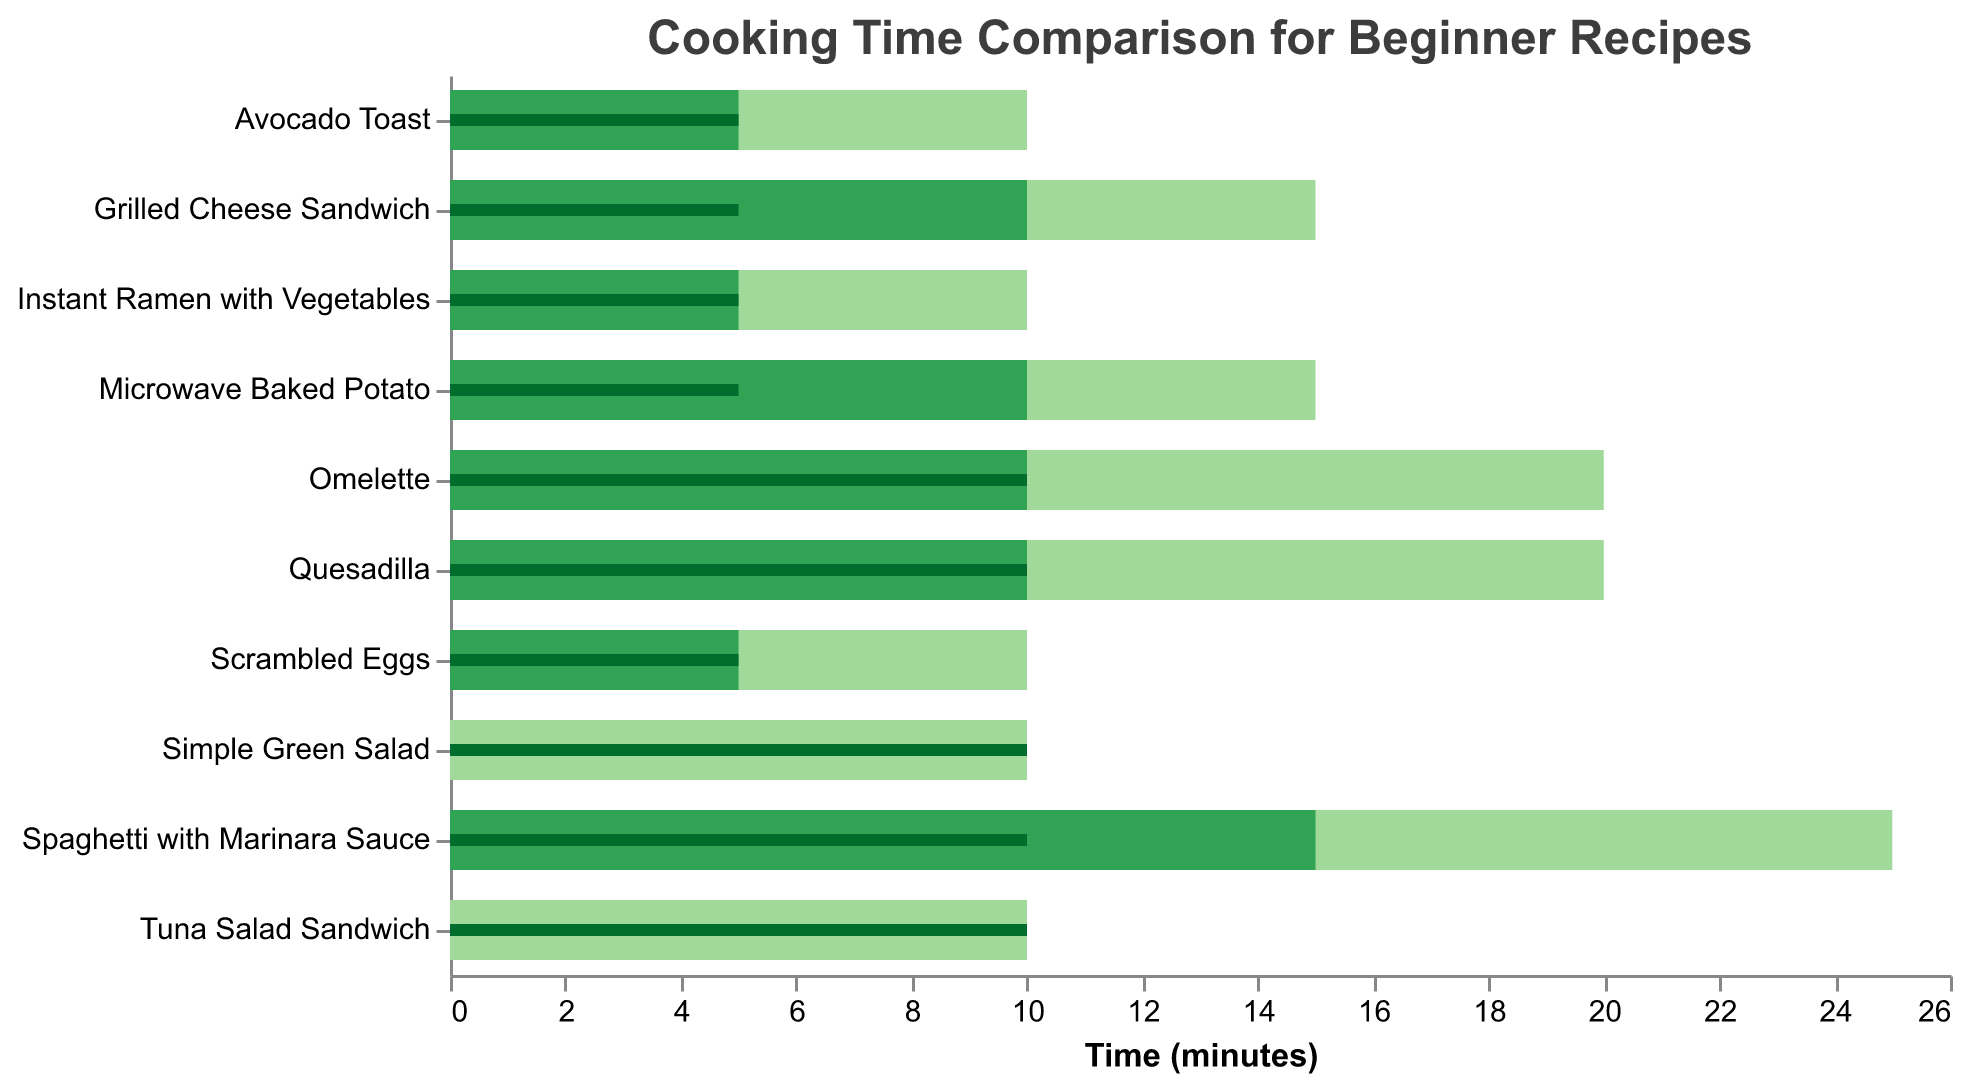What is the title of the figure? The title of the figure is located at the top and is usually in a larger font size for emphasis.
Answer: Cooking Time Comparison for Beginner Recipes How many recipes take 10 minutes in total to prepare? By looking at the "Total Time (min)" values, we can count the recipes with 10 minutes total time: Scrambled Eggs, Simple Green Salad, Avocado Toast, Tuna Salad Sandwich, and Instant Ramen with Vegetables.
Answer: 5 Which recipe has the longest total time? Compare the "Total Time (min)" values for each recipe and identify the highest one, which is 25 minutes for Spaghetti with Marinara Sauce.
Answer: Spaghetti with Marinara Sauce What are the prep and cooking times for Grilled Cheese Sandwich? Find the bar representing Grilled Cheese Sandwich and observe the "Prep Time (min)" and "Cooking Time (min)" widths: Prep Time is 5 minutes, and Cooking Time is 10 minutes.
Answer: Prep Time: 5 min, Cooking Time: 10 min Which two recipes have the same total time but different prep and cooking times? Identify recipes with equal "Total Time (min)" but compare their "Prep Time (min)" and "Cooking Time (min)". Quesadilla and Omelette both total 20 minutes but have 10 min prep and 10 min cooking.
Answer: Quesadilla and Omelette What is the total time difference between Scrambled Eggs and Spaghetti with Marinara Sauce? Subtract the "Total Time (min)" for Scrambled Eggs (10 minutes) from Spaghetti with Marinara Sauce (25 minutes): 25 - 10.
Answer: 15 minutes Is there any recipe that requires no cooking time? Look for recipes where "Cooking Time (min)" is 0. Simple Green Salad and Tuna Salad Sandwich each meet this criterion.
Answer: Yes, Simple Green Salad and Tuna Salad Sandwich Which recipe has a shorter cooking time than prep time? By comparing the "Prep Time (min)" and "Cooking Time (min)" for each recipe, none have shorter cooking than prep time.
Answer: None For how many recipes is the cooking time equal to the prep time? Check for recipes where "Prep Time (min)" equals "Cooking Time (min)": Scrambled Eggs, Avocado Toast, Omelette, Quesadilla, and Instant Ramen with Vegetables.
Answer: 5 